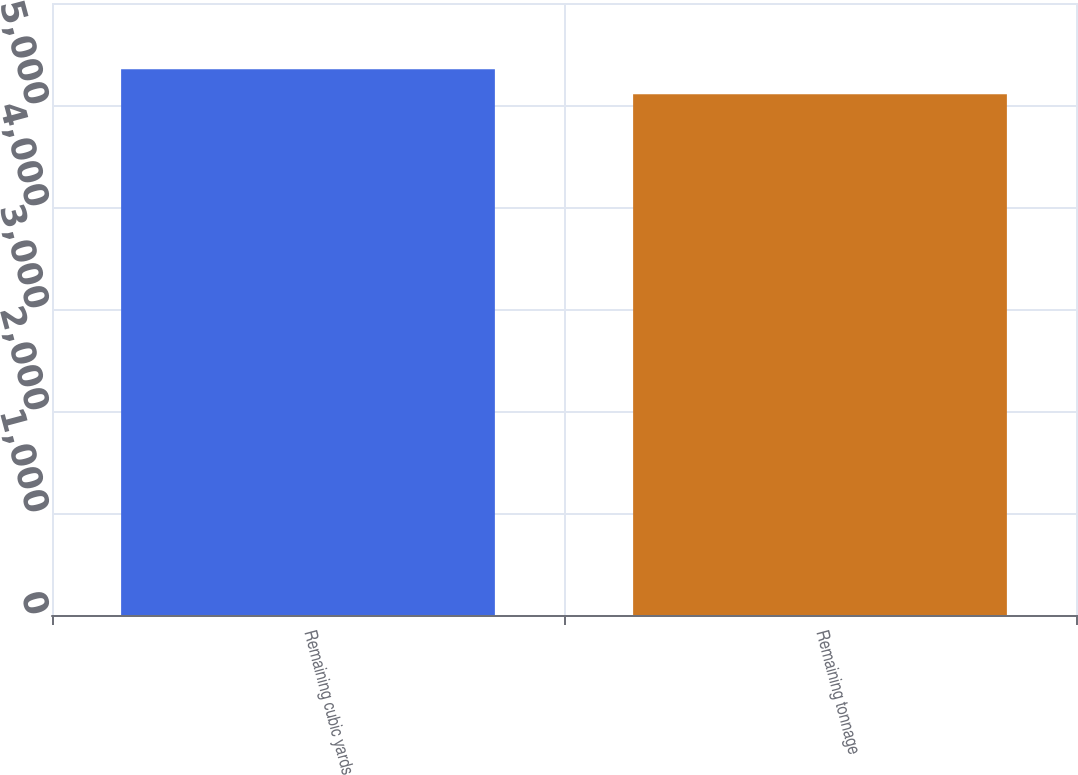<chart> <loc_0><loc_0><loc_500><loc_500><bar_chart><fcel>Remaining cubic yards<fcel>Remaining tonnage<nl><fcel>5351<fcel>5106<nl></chart> 